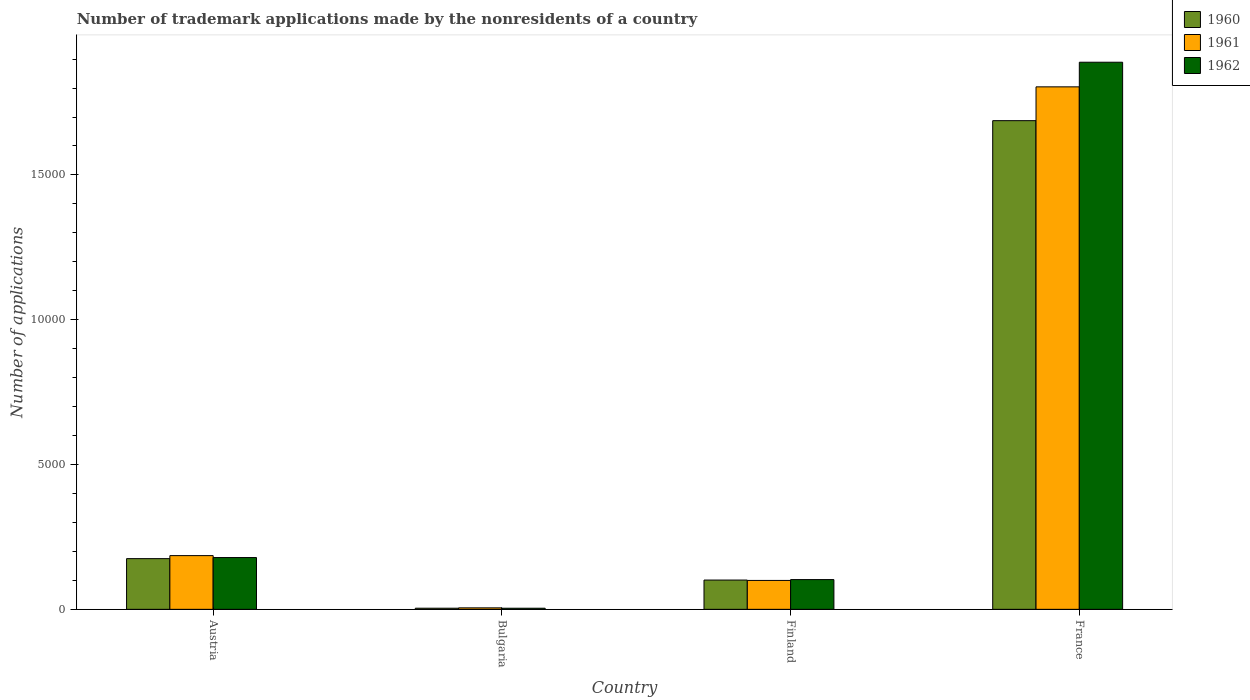How many groups of bars are there?
Your response must be concise. 4. How many bars are there on the 4th tick from the right?
Provide a succinct answer. 3. In how many cases, is the number of bars for a given country not equal to the number of legend labels?
Your answer should be compact. 0. What is the number of trademark applications made by the nonresidents in 1961 in France?
Ensure brevity in your answer.  1.80e+04. Across all countries, what is the maximum number of trademark applications made by the nonresidents in 1962?
Your answer should be compact. 1.89e+04. Across all countries, what is the minimum number of trademark applications made by the nonresidents in 1962?
Offer a terse response. 38. In which country was the number of trademark applications made by the nonresidents in 1960 maximum?
Provide a short and direct response. France. What is the total number of trademark applications made by the nonresidents in 1961 in the graph?
Give a very brief answer. 2.09e+04. What is the difference between the number of trademark applications made by the nonresidents in 1961 in Bulgaria and that in Finland?
Ensure brevity in your answer.  -947. What is the difference between the number of trademark applications made by the nonresidents in 1961 in Finland and the number of trademark applications made by the nonresidents in 1960 in France?
Your answer should be very brief. -1.59e+04. What is the average number of trademark applications made by the nonresidents in 1960 per country?
Provide a succinct answer. 4918.75. What is the difference between the number of trademark applications made by the nonresidents of/in 1961 and number of trademark applications made by the nonresidents of/in 1960 in Bulgaria?
Give a very brief answer. 12. What is the ratio of the number of trademark applications made by the nonresidents in 1960 in Austria to that in Bulgaria?
Your answer should be compact. 44.9. Is the number of trademark applications made by the nonresidents in 1962 in Bulgaria less than that in Finland?
Offer a very short reply. Yes. Is the difference between the number of trademark applications made by the nonresidents in 1961 in Austria and Finland greater than the difference between the number of trademark applications made by the nonresidents in 1960 in Austria and Finland?
Provide a succinct answer. Yes. What is the difference between the highest and the second highest number of trademark applications made by the nonresidents in 1960?
Keep it short and to the point. 1.59e+04. What is the difference between the highest and the lowest number of trademark applications made by the nonresidents in 1960?
Your answer should be very brief. 1.68e+04. In how many countries, is the number of trademark applications made by the nonresidents in 1961 greater than the average number of trademark applications made by the nonresidents in 1961 taken over all countries?
Provide a short and direct response. 1. Is the sum of the number of trademark applications made by the nonresidents in 1961 in Austria and France greater than the maximum number of trademark applications made by the nonresidents in 1962 across all countries?
Make the answer very short. Yes. Is it the case that in every country, the sum of the number of trademark applications made by the nonresidents in 1960 and number of trademark applications made by the nonresidents in 1962 is greater than the number of trademark applications made by the nonresidents in 1961?
Make the answer very short. Yes. How many bars are there?
Give a very brief answer. 12. How many legend labels are there?
Give a very brief answer. 3. What is the title of the graph?
Your answer should be compact. Number of trademark applications made by the nonresidents of a country. What is the label or title of the Y-axis?
Provide a short and direct response. Number of applications. What is the Number of applications in 1960 in Austria?
Offer a very short reply. 1751. What is the Number of applications of 1961 in Austria?
Provide a succinct answer. 1855. What is the Number of applications of 1962 in Austria?
Your response must be concise. 1788. What is the Number of applications in 1961 in Bulgaria?
Offer a very short reply. 51. What is the Number of applications in 1960 in Finland?
Ensure brevity in your answer.  1011. What is the Number of applications of 1961 in Finland?
Keep it short and to the point. 998. What is the Number of applications in 1962 in Finland?
Your answer should be compact. 1027. What is the Number of applications in 1960 in France?
Your answer should be compact. 1.69e+04. What is the Number of applications of 1961 in France?
Provide a succinct answer. 1.80e+04. What is the Number of applications of 1962 in France?
Your answer should be compact. 1.89e+04. Across all countries, what is the maximum Number of applications of 1960?
Your response must be concise. 1.69e+04. Across all countries, what is the maximum Number of applications of 1961?
Give a very brief answer. 1.80e+04. Across all countries, what is the maximum Number of applications in 1962?
Ensure brevity in your answer.  1.89e+04. What is the total Number of applications of 1960 in the graph?
Offer a very short reply. 1.97e+04. What is the total Number of applications in 1961 in the graph?
Give a very brief answer. 2.09e+04. What is the total Number of applications in 1962 in the graph?
Your answer should be very brief. 2.17e+04. What is the difference between the Number of applications of 1960 in Austria and that in Bulgaria?
Your answer should be very brief. 1712. What is the difference between the Number of applications in 1961 in Austria and that in Bulgaria?
Ensure brevity in your answer.  1804. What is the difference between the Number of applications in 1962 in Austria and that in Bulgaria?
Keep it short and to the point. 1750. What is the difference between the Number of applications of 1960 in Austria and that in Finland?
Ensure brevity in your answer.  740. What is the difference between the Number of applications in 1961 in Austria and that in Finland?
Your answer should be compact. 857. What is the difference between the Number of applications in 1962 in Austria and that in Finland?
Offer a terse response. 761. What is the difference between the Number of applications of 1960 in Austria and that in France?
Make the answer very short. -1.51e+04. What is the difference between the Number of applications of 1961 in Austria and that in France?
Your answer should be compact. -1.62e+04. What is the difference between the Number of applications of 1962 in Austria and that in France?
Your response must be concise. -1.71e+04. What is the difference between the Number of applications of 1960 in Bulgaria and that in Finland?
Give a very brief answer. -972. What is the difference between the Number of applications in 1961 in Bulgaria and that in Finland?
Your answer should be very brief. -947. What is the difference between the Number of applications in 1962 in Bulgaria and that in Finland?
Provide a succinct answer. -989. What is the difference between the Number of applications in 1960 in Bulgaria and that in France?
Keep it short and to the point. -1.68e+04. What is the difference between the Number of applications in 1961 in Bulgaria and that in France?
Offer a terse response. -1.80e+04. What is the difference between the Number of applications of 1962 in Bulgaria and that in France?
Provide a succinct answer. -1.89e+04. What is the difference between the Number of applications of 1960 in Finland and that in France?
Provide a short and direct response. -1.59e+04. What is the difference between the Number of applications in 1961 in Finland and that in France?
Offer a terse response. -1.70e+04. What is the difference between the Number of applications in 1962 in Finland and that in France?
Offer a terse response. -1.79e+04. What is the difference between the Number of applications of 1960 in Austria and the Number of applications of 1961 in Bulgaria?
Your answer should be very brief. 1700. What is the difference between the Number of applications in 1960 in Austria and the Number of applications in 1962 in Bulgaria?
Offer a very short reply. 1713. What is the difference between the Number of applications of 1961 in Austria and the Number of applications of 1962 in Bulgaria?
Ensure brevity in your answer.  1817. What is the difference between the Number of applications of 1960 in Austria and the Number of applications of 1961 in Finland?
Give a very brief answer. 753. What is the difference between the Number of applications in 1960 in Austria and the Number of applications in 1962 in Finland?
Your answer should be compact. 724. What is the difference between the Number of applications in 1961 in Austria and the Number of applications in 1962 in Finland?
Keep it short and to the point. 828. What is the difference between the Number of applications of 1960 in Austria and the Number of applications of 1961 in France?
Give a very brief answer. -1.63e+04. What is the difference between the Number of applications in 1960 in Austria and the Number of applications in 1962 in France?
Ensure brevity in your answer.  -1.71e+04. What is the difference between the Number of applications of 1961 in Austria and the Number of applications of 1962 in France?
Give a very brief answer. -1.70e+04. What is the difference between the Number of applications of 1960 in Bulgaria and the Number of applications of 1961 in Finland?
Your answer should be compact. -959. What is the difference between the Number of applications of 1960 in Bulgaria and the Number of applications of 1962 in Finland?
Ensure brevity in your answer.  -988. What is the difference between the Number of applications in 1961 in Bulgaria and the Number of applications in 1962 in Finland?
Make the answer very short. -976. What is the difference between the Number of applications in 1960 in Bulgaria and the Number of applications in 1961 in France?
Give a very brief answer. -1.80e+04. What is the difference between the Number of applications in 1960 in Bulgaria and the Number of applications in 1962 in France?
Give a very brief answer. -1.89e+04. What is the difference between the Number of applications of 1961 in Bulgaria and the Number of applications of 1962 in France?
Keep it short and to the point. -1.88e+04. What is the difference between the Number of applications in 1960 in Finland and the Number of applications in 1961 in France?
Ensure brevity in your answer.  -1.70e+04. What is the difference between the Number of applications in 1960 in Finland and the Number of applications in 1962 in France?
Your response must be concise. -1.79e+04. What is the difference between the Number of applications of 1961 in Finland and the Number of applications of 1962 in France?
Offer a very short reply. -1.79e+04. What is the average Number of applications in 1960 per country?
Offer a terse response. 4918.75. What is the average Number of applications in 1961 per country?
Give a very brief answer. 5236.5. What is the average Number of applications in 1962 per country?
Offer a terse response. 5436.25. What is the difference between the Number of applications of 1960 and Number of applications of 1961 in Austria?
Your answer should be compact. -104. What is the difference between the Number of applications in 1960 and Number of applications in 1962 in Austria?
Ensure brevity in your answer.  -37. What is the difference between the Number of applications in 1960 and Number of applications in 1961 in Bulgaria?
Offer a very short reply. -12. What is the difference between the Number of applications in 1960 and Number of applications in 1962 in Bulgaria?
Give a very brief answer. 1. What is the difference between the Number of applications in 1961 and Number of applications in 1962 in Bulgaria?
Give a very brief answer. 13. What is the difference between the Number of applications in 1960 and Number of applications in 1961 in France?
Your answer should be compact. -1168. What is the difference between the Number of applications of 1960 and Number of applications of 1962 in France?
Keep it short and to the point. -2018. What is the difference between the Number of applications of 1961 and Number of applications of 1962 in France?
Provide a short and direct response. -850. What is the ratio of the Number of applications of 1960 in Austria to that in Bulgaria?
Your answer should be compact. 44.9. What is the ratio of the Number of applications in 1961 in Austria to that in Bulgaria?
Keep it short and to the point. 36.37. What is the ratio of the Number of applications in 1962 in Austria to that in Bulgaria?
Provide a succinct answer. 47.05. What is the ratio of the Number of applications of 1960 in Austria to that in Finland?
Give a very brief answer. 1.73. What is the ratio of the Number of applications of 1961 in Austria to that in Finland?
Your response must be concise. 1.86. What is the ratio of the Number of applications in 1962 in Austria to that in Finland?
Offer a terse response. 1.74. What is the ratio of the Number of applications of 1960 in Austria to that in France?
Offer a terse response. 0.1. What is the ratio of the Number of applications in 1961 in Austria to that in France?
Offer a very short reply. 0.1. What is the ratio of the Number of applications in 1962 in Austria to that in France?
Provide a succinct answer. 0.09. What is the ratio of the Number of applications in 1960 in Bulgaria to that in Finland?
Your answer should be very brief. 0.04. What is the ratio of the Number of applications in 1961 in Bulgaria to that in Finland?
Give a very brief answer. 0.05. What is the ratio of the Number of applications of 1962 in Bulgaria to that in Finland?
Your response must be concise. 0.04. What is the ratio of the Number of applications of 1960 in Bulgaria to that in France?
Your response must be concise. 0. What is the ratio of the Number of applications of 1961 in Bulgaria to that in France?
Offer a very short reply. 0. What is the ratio of the Number of applications in 1962 in Bulgaria to that in France?
Your answer should be compact. 0. What is the ratio of the Number of applications of 1960 in Finland to that in France?
Your response must be concise. 0.06. What is the ratio of the Number of applications in 1961 in Finland to that in France?
Your answer should be very brief. 0.06. What is the ratio of the Number of applications in 1962 in Finland to that in France?
Your answer should be compact. 0.05. What is the difference between the highest and the second highest Number of applications in 1960?
Offer a very short reply. 1.51e+04. What is the difference between the highest and the second highest Number of applications of 1961?
Your answer should be very brief. 1.62e+04. What is the difference between the highest and the second highest Number of applications of 1962?
Offer a terse response. 1.71e+04. What is the difference between the highest and the lowest Number of applications in 1960?
Give a very brief answer. 1.68e+04. What is the difference between the highest and the lowest Number of applications in 1961?
Keep it short and to the point. 1.80e+04. What is the difference between the highest and the lowest Number of applications of 1962?
Give a very brief answer. 1.89e+04. 